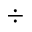Convert formula to latex. <formula><loc_0><loc_0><loc_500><loc_500>\div</formula> 